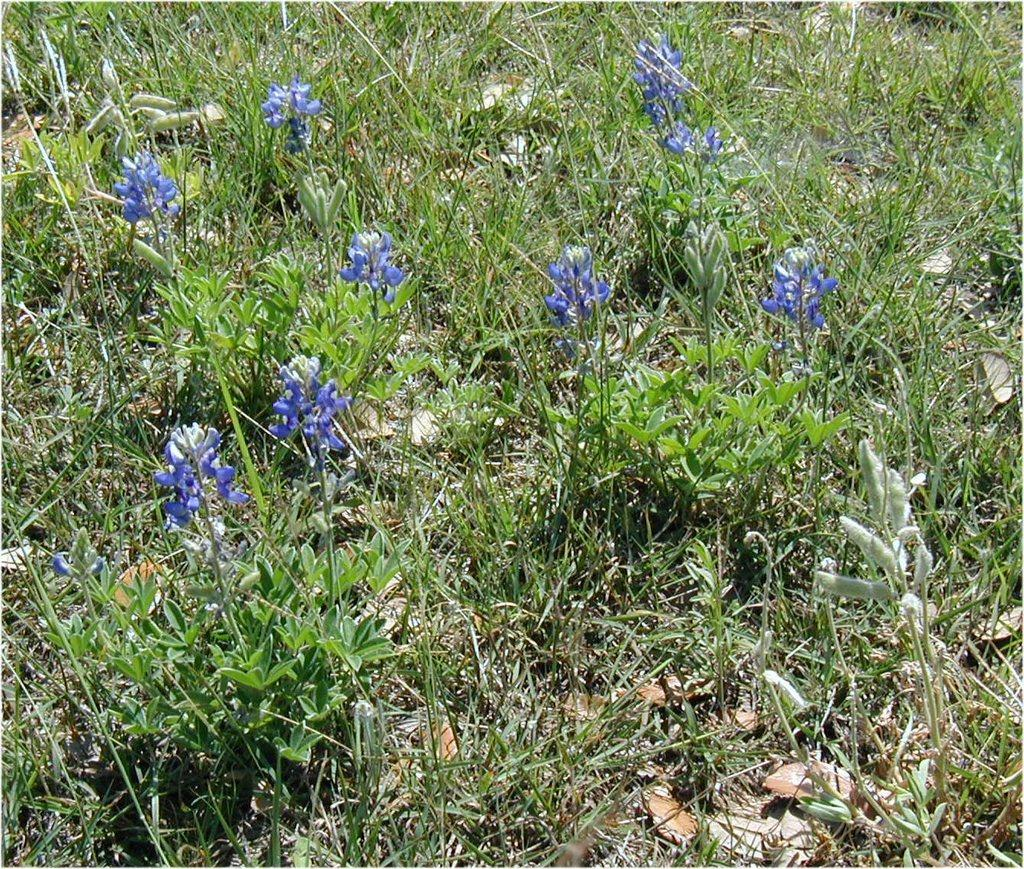What type of plants can be seen in the image? There are flowering plants in the image. What is on the ground in the image? There is grass on the ground in the image. Can you describe the possible setting of the image? The image may have been taken in a farm. How many ants can be seen crawling on the car in the image? There is no car present in the image, and therefore no ants can be seen crawling on it. 